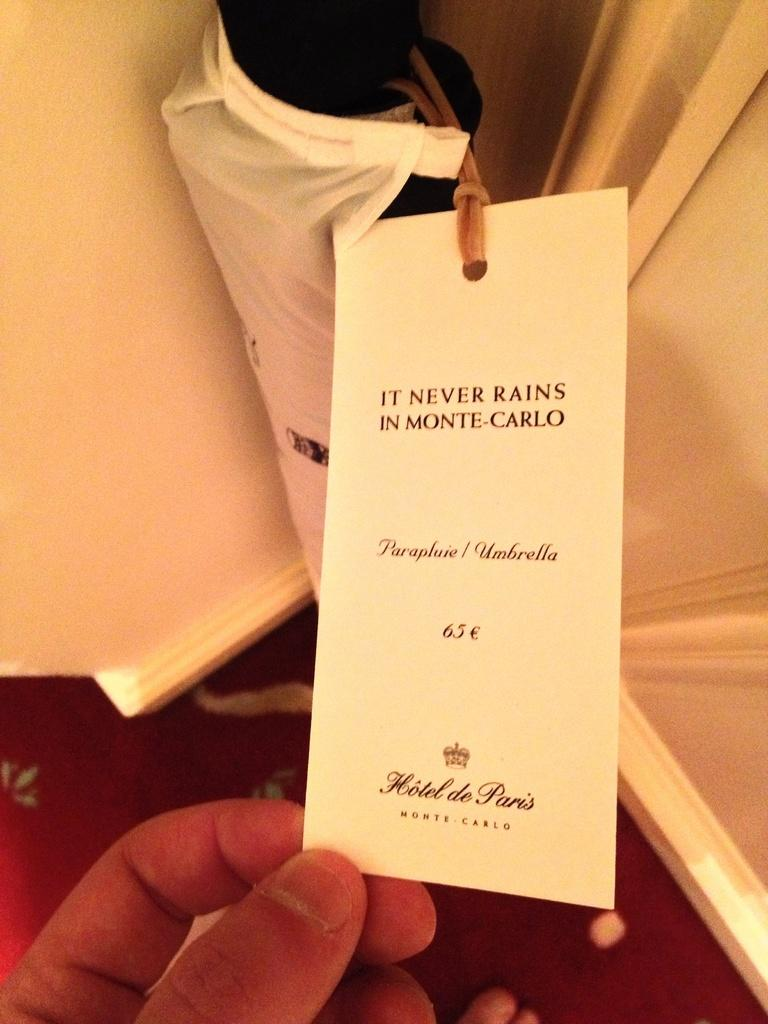What is the main subject of the image? There is a person in the image. What is the person holding in the image? The person is holding a tag. What is the tag placed on in the image? There is a cloth under the tag. What type of rice can be seen growing on the plants in the image? There are no plants or rice present in the image; it features a person holding a tag on a cloth. 